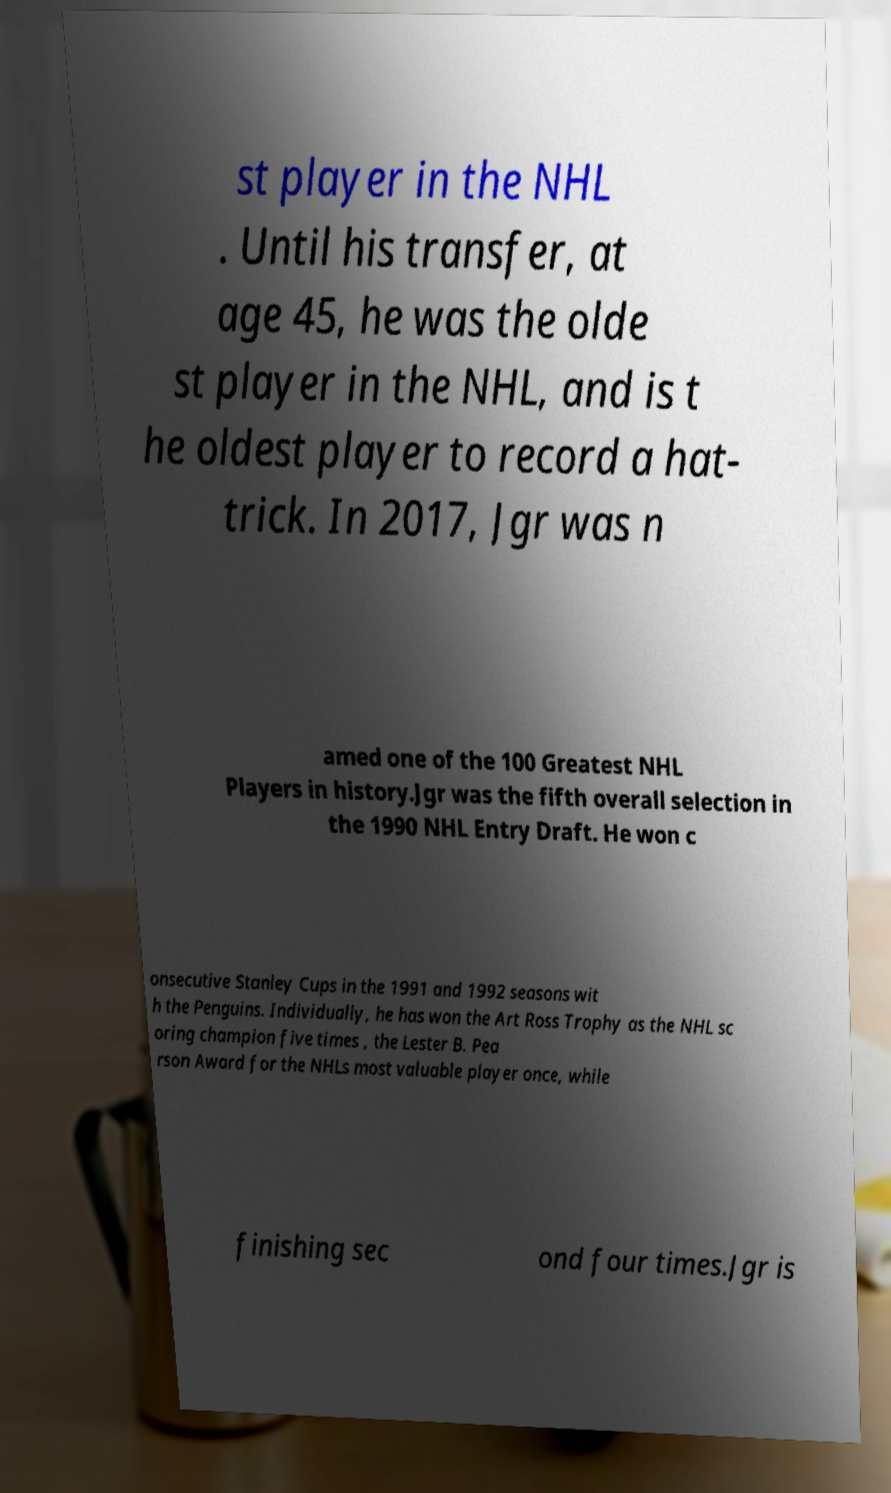Can you read and provide the text displayed in the image?This photo seems to have some interesting text. Can you extract and type it out for me? st player in the NHL . Until his transfer, at age 45, he was the olde st player in the NHL, and is t he oldest player to record a hat- trick. In 2017, Jgr was n amed one of the 100 Greatest NHL Players in history.Jgr was the fifth overall selection in the 1990 NHL Entry Draft. He won c onsecutive Stanley Cups in the 1991 and 1992 seasons wit h the Penguins. Individually, he has won the Art Ross Trophy as the NHL sc oring champion five times , the Lester B. Pea rson Award for the NHLs most valuable player once, while finishing sec ond four times.Jgr is 